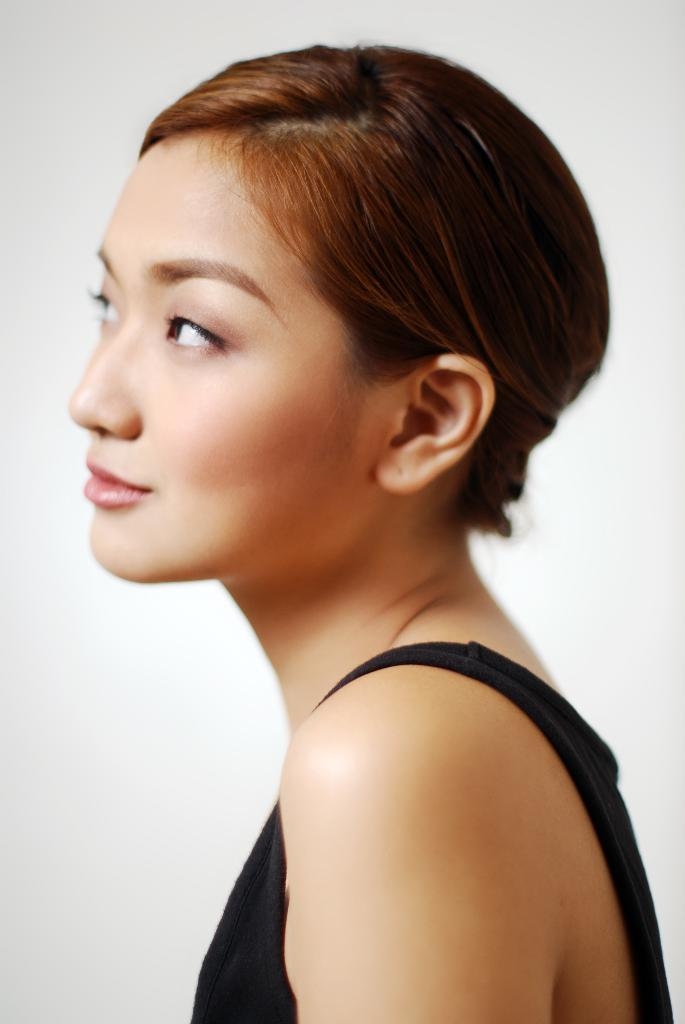Who is present in the image? There is a woman in the image. What type of tent is the woman painting in the image? There is no tent or painting activity present in the image; it only features a woman. 